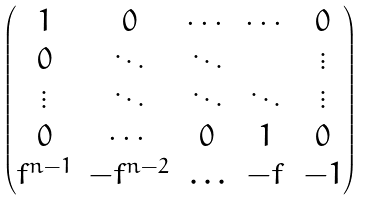Convert formula to latex. <formula><loc_0><loc_0><loc_500><loc_500>\begin{pmatrix} 1 & 0 & \cdots & \cdots & 0 \\ 0 & \ddots & \ddots & & \vdots \\ \vdots & \ddots & \ddots & \ddots & \vdots \\ 0 & \cdots & 0 & 1 & 0 \\ f ^ { n - 1 } & - f ^ { n - 2 } & \hdots & - f & - 1 \end{pmatrix}</formula> 